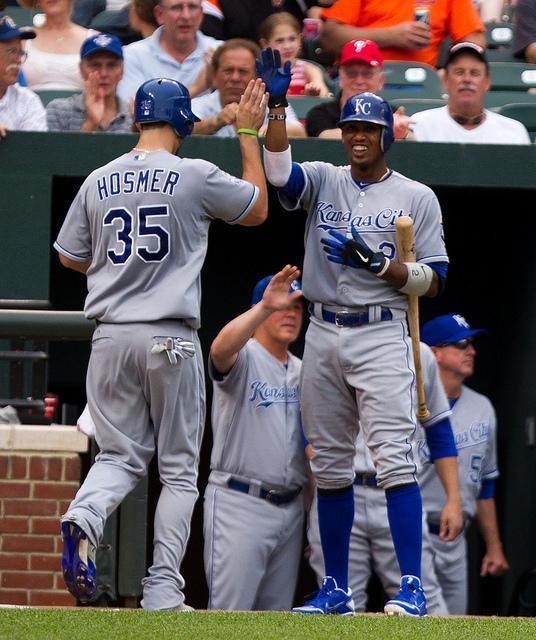How many people are in the picture?
Give a very brief answer. 13. 